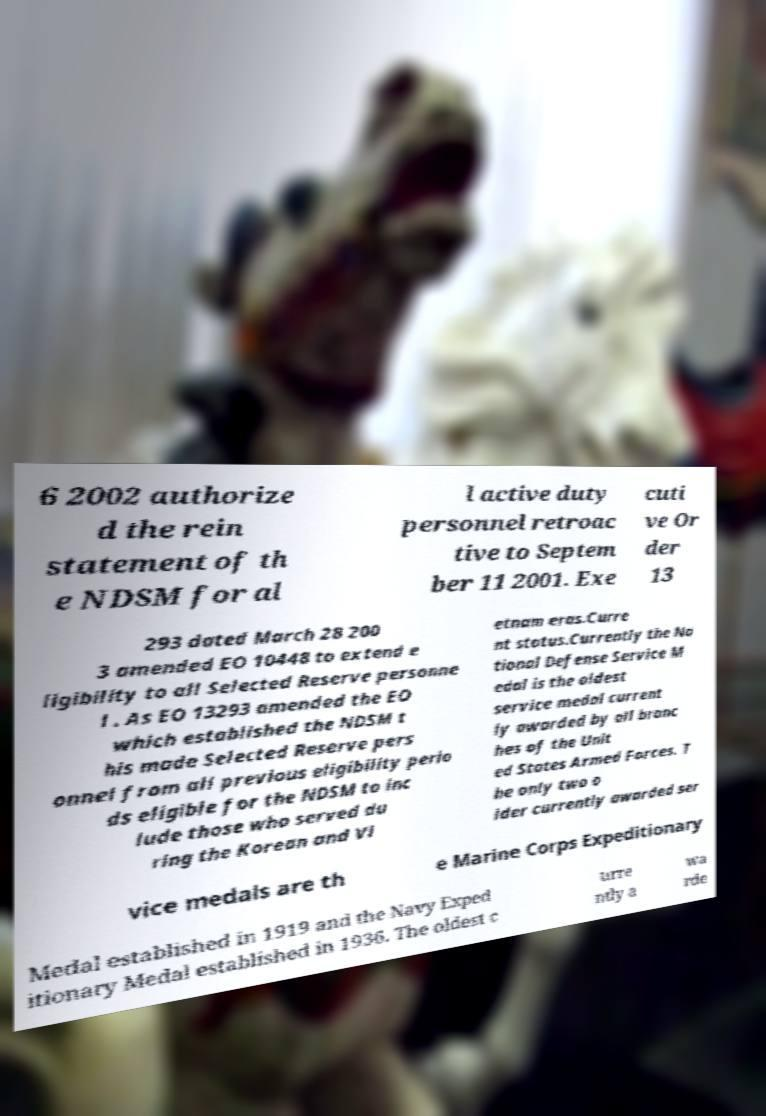Please read and relay the text visible in this image. What does it say? 6 2002 authorize d the rein statement of th e NDSM for al l active duty personnel retroac tive to Septem ber 11 2001. Exe cuti ve Or der 13 293 dated March 28 200 3 amended EO 10448 to extend e ligibility to all Selected Reserve personne l . As EO 13293 amended the EO which established the NDSM t his made Selected Reserve pers onnel from all previous eligibility perio ds eligible for the NDSM to inc lude those who served du ring the Korean and Vi etnam eras.Curre nt status.Currently the Na tional Defense Service M edal is the oldest service medal current ly awarded by all branc hes of the Unit ed States Armed Forces. T he only two o lder currently awarded ser vice medals are th e Marine Corps Expeditionary Medal established in 1919 and the Navy Exped itionary Medal established in 1936. The oldest c urre ntly a wa rde 